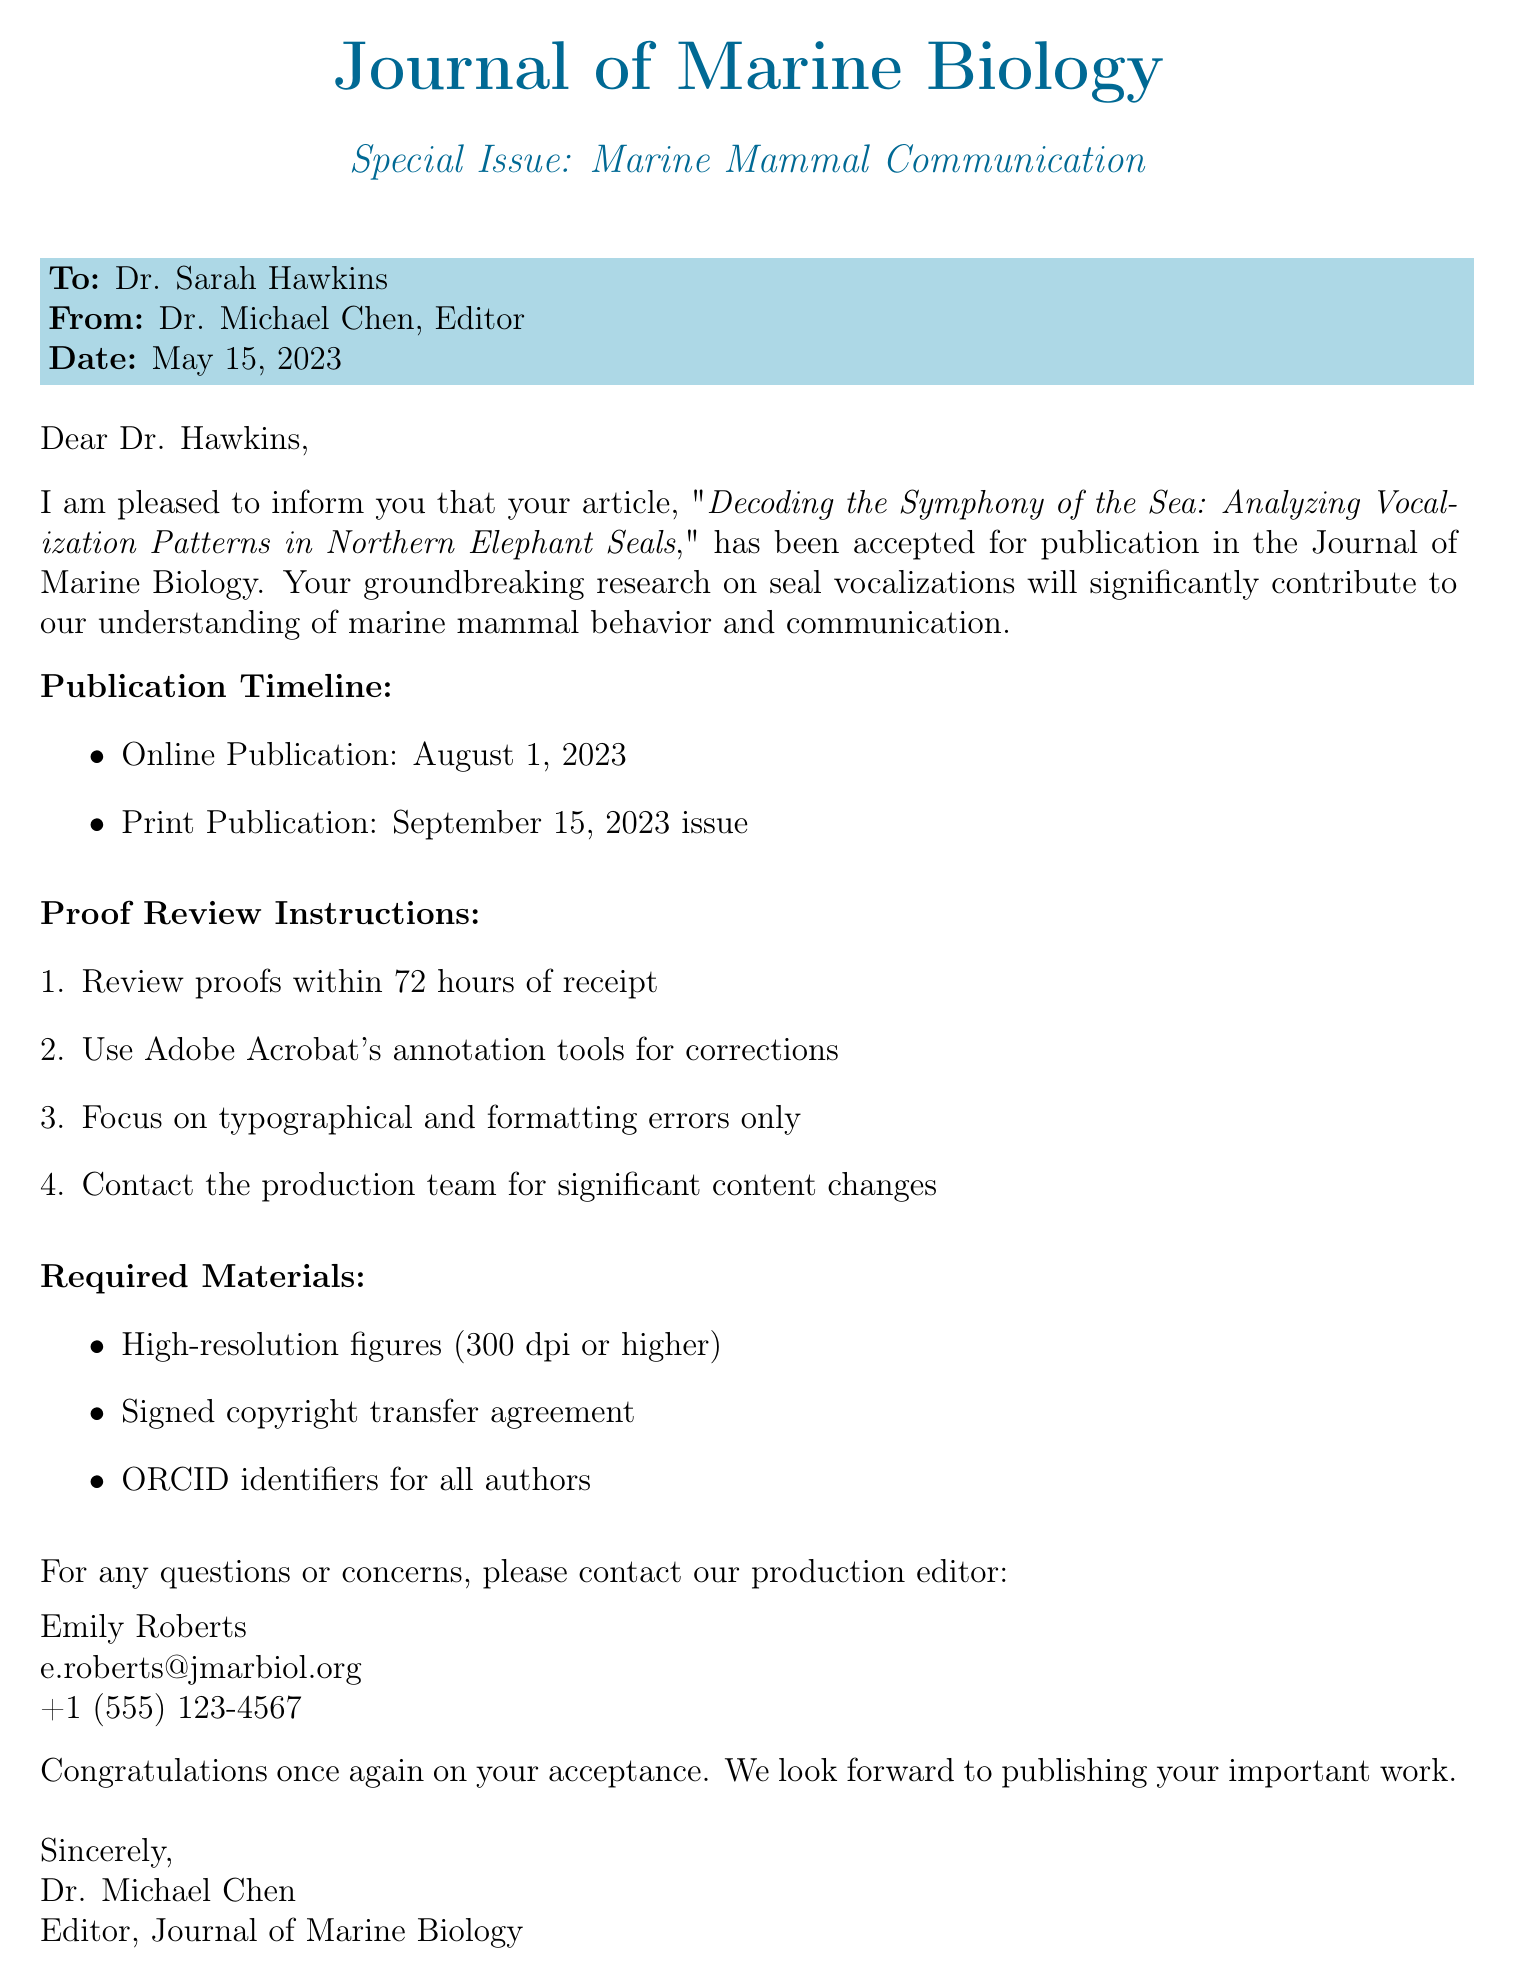What is the title of the article? The title is explicitly stated in the document.
Answer: Decoding the Symphony of the Sea: Analyzing Vocalization Patterns in Northern Elephant Seals Who is the editor of the journal? The editor's name is mentioned in the document.
Answer: Dr. Michael Chen When was the article accepted? The acceptance date is provided in the document.
Answer: May 15, 2023 What is the online publication date? The document specifies the online publication timeline.
Answer: August 1, 2023 What should be focused on during the proof review? The document outlines specific content to review.
Answer: Typographical and formatting errors only What is required for the copyright transfer? The document lists required materials for publication.
Answer: Signed copyright transfer agreement Who should be contacted for questions? The document provides contact information for the production editor.
Answer: Emily Roberts In which special issue does this article appear? The document notes the special issue related to the article.
Answer: Marine Mammal Communication What tools are recommended for corrections during proof review? The document specifies the tool for making corrections.
Answer: Adobe Acrobat's annotation tools 